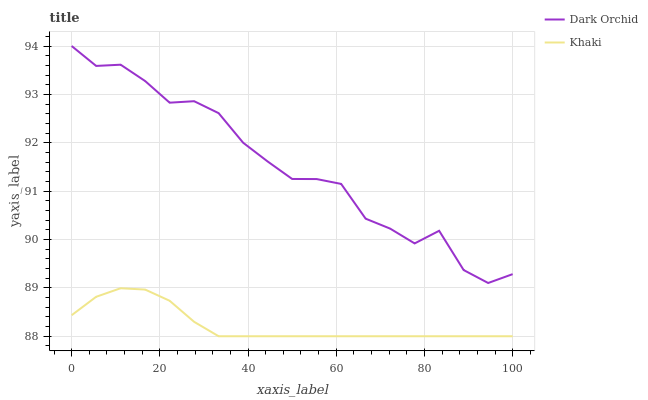Does Khaki have the minimum area under the curve?
Answer yes or no. Yes. Does Dark Orchid have the maximum area under the curve?
Answer yes or no. Yes. Does Dark Orchid have the minimum area under the curve?
Answer yes or no. No. Is Khaki the smoothest?
Answer yes or no. Yes. Is Dark Orchid the roughest?
Answer yes or no. Yes. Is Dark Orchid the smoothest?
Answer yes or no. No. Does Khaki have the lowest value?
Answer yes or no. Yes. Does Dark Orchid have the lowest value?
Answer yes or no. No. Does Dark Orchid have the highest value?
Answer yes or no. Yes. Is Khaki less than Dark Orchid?
Answer yes or no. Yes. Is Dark Orchid greater than Khaki?
Answer yes or no. Yes. Does Khaki intersect Dark Orchid?
Answer yes or no. No. 